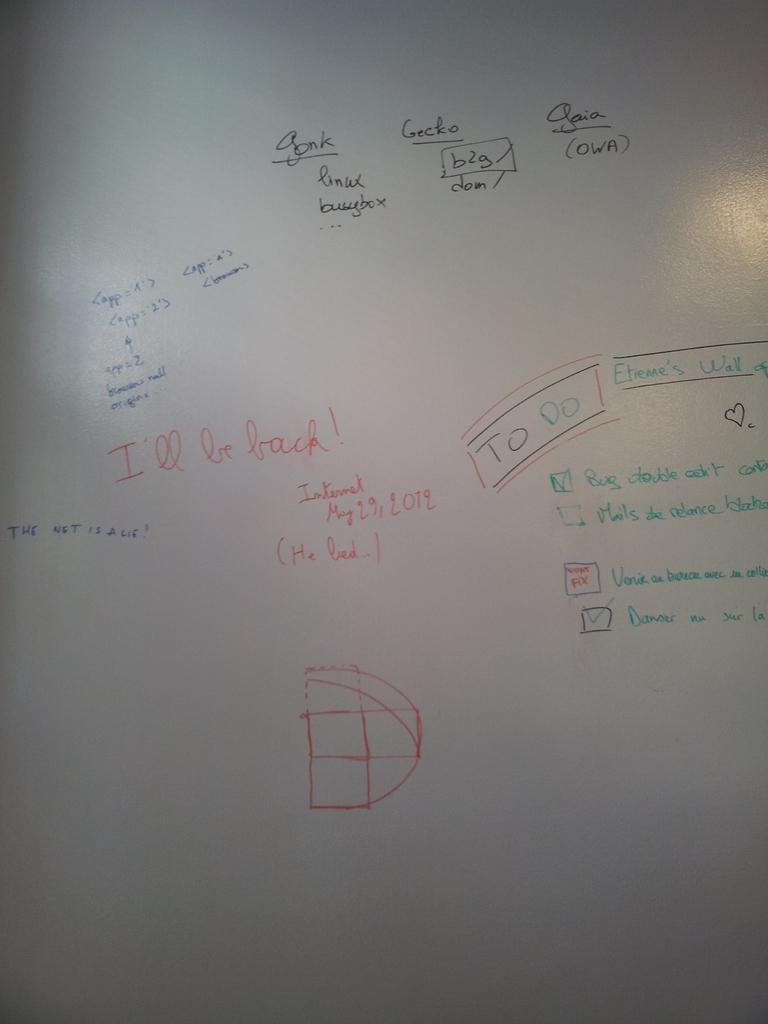Provide a one-sentence caption for the provided image. A white board with various writings including I'll be back. 